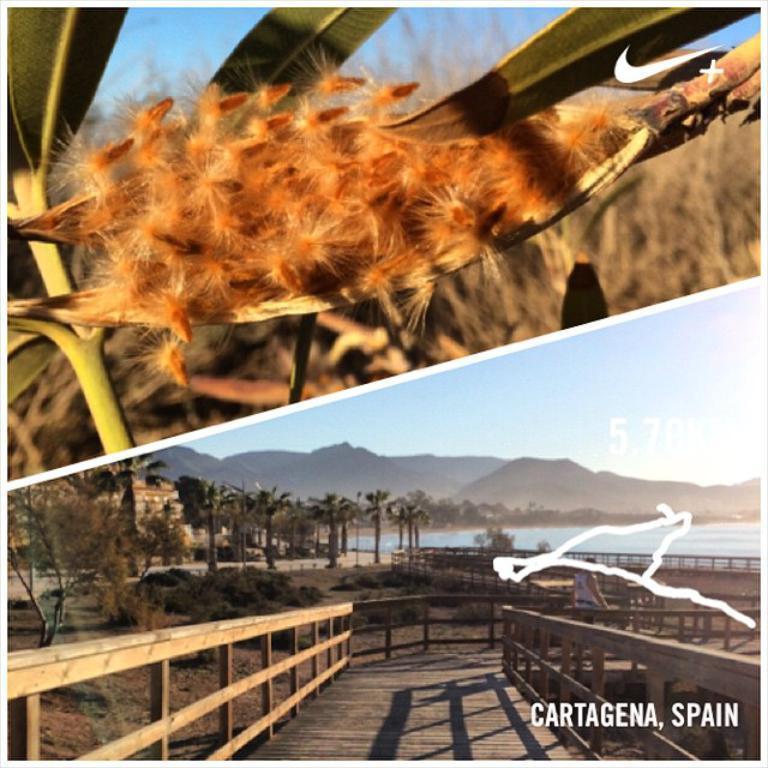In one or two sentences, can you explain what this image depicts? This image is a collage of two images. At the bottom of the image there is a wooden platform. There is a railing. There are a few trees and plants on the ground. There is a river with water. There are a few hills and there is the sky with clouds. A man is sitting on the bench. At the top of the image there is the sky. There are a few plants with leaves and stems. 